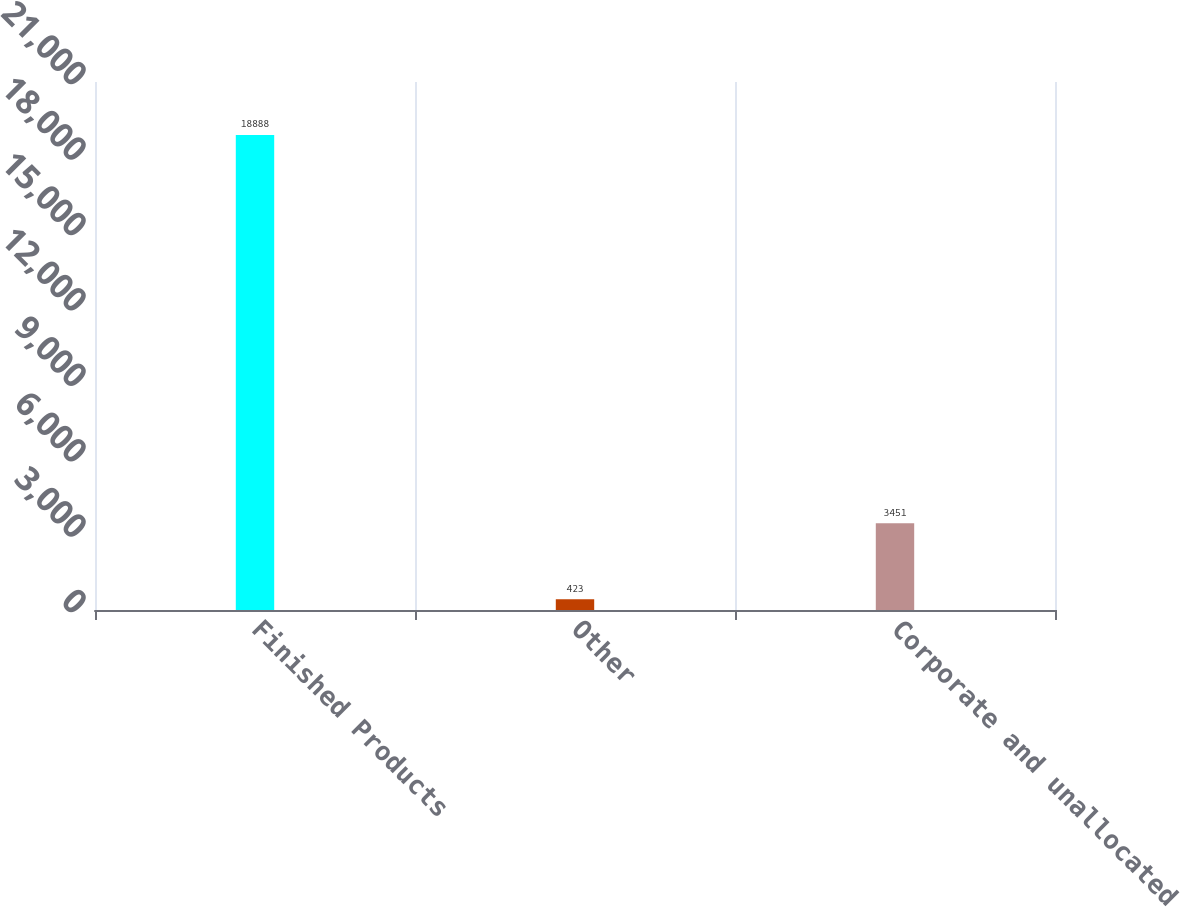Convert chart. <chart><loc_0><loc_0><loc_500><loc_500><bar_chart><fcel>Finished Products<fcel>Other<fcel>Corporate and unallocated<nl><fcel>18888<fcel>423<fcel>3451<nl></chart> 